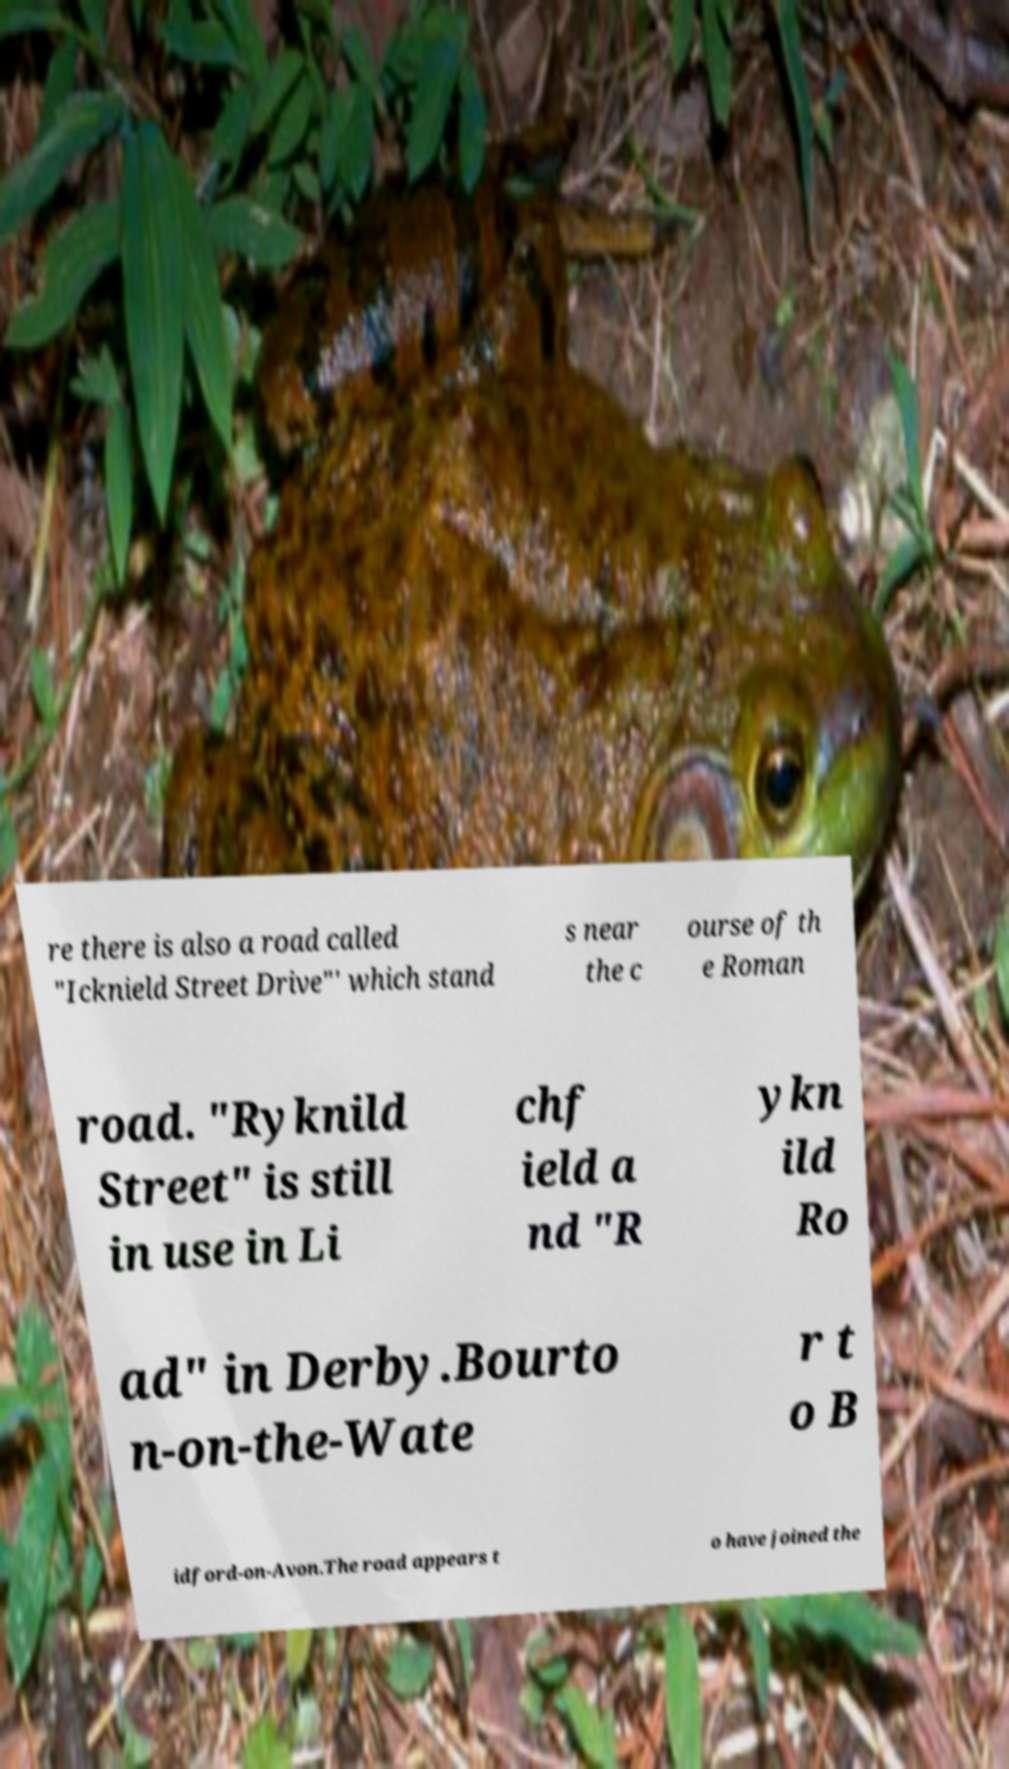For documentation purposes, I need the text within this image transcribed. Could you provide that? re there is also a road called "Icknield Street Drive"' which stand s near the c ourse of th e Roman road. "Ryknild Street" is still in use in Li chf ield a nd "R ykn ild Ro ad" in Derby.Bourto n-on-the-Wate r t o B idford-on-Avon.The road appears t o have joined the 